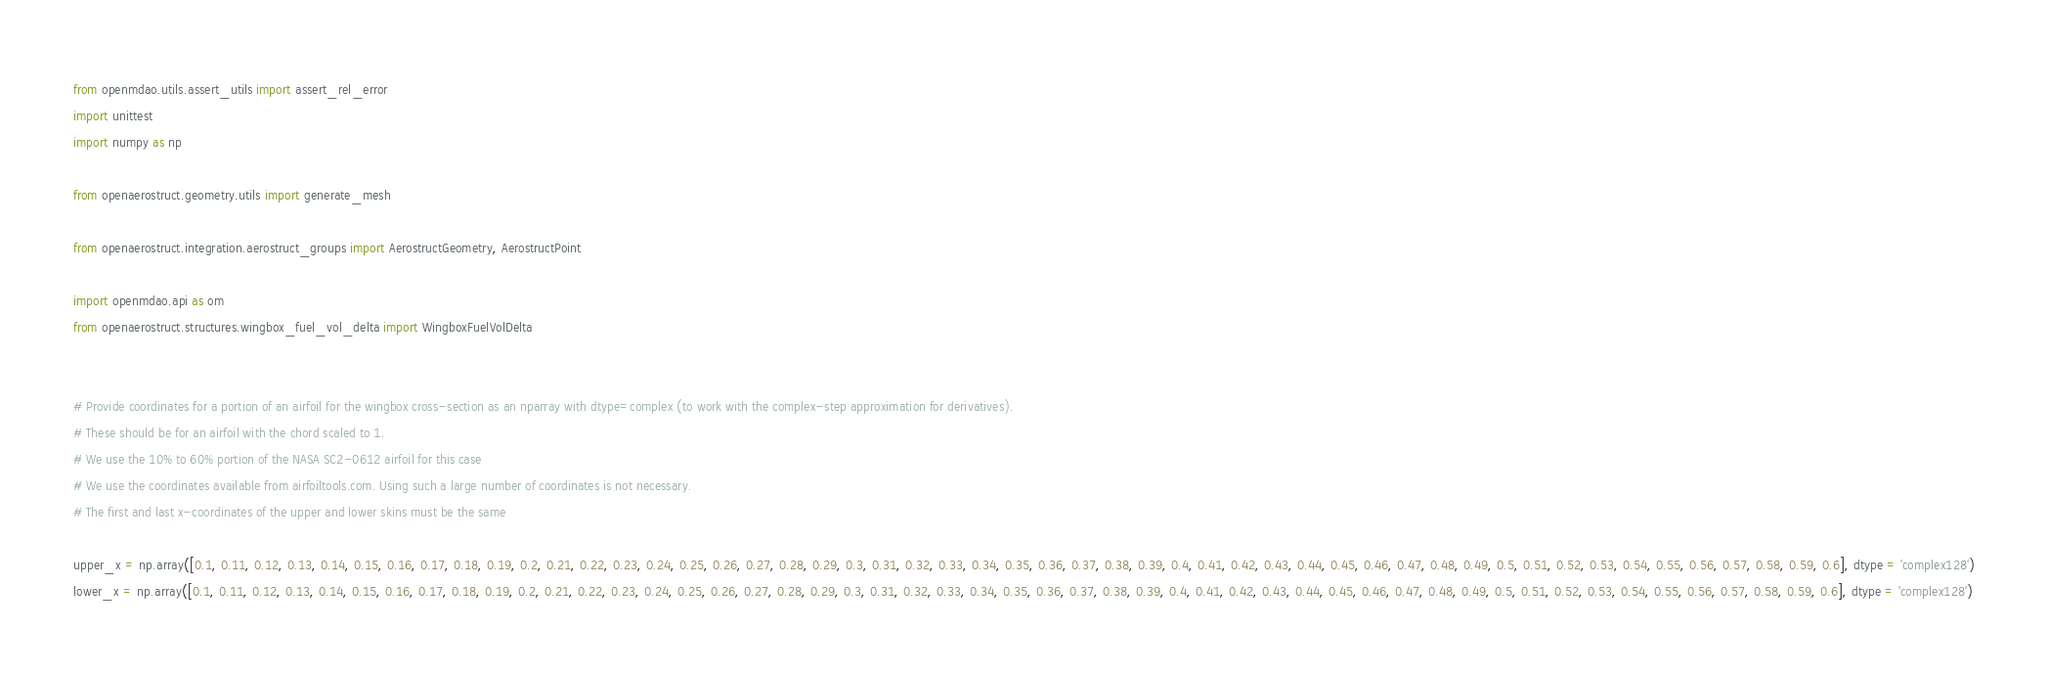Convert code to text. <code><loc_0><loc_0><loc_500><loc_500><_Python_>from openmdao.utils.assert_utils import assert_rel_error
import unittest
import numpy as np

from openaerostruct.geometry.utils import generate_mesh

from openaerostruct.integration.aerostruct_groups import AerostructGeometry, AerostructPoint

import openmdao.api as om
from openaerostruct.structures.wingbox_fuel_vol_delta import WingboxFuelVolDelta


# Provide coordinates for a portion of an airfoil for the wingbox cross-section as an nparray with dtype=complex (to work with the complex-step approximation for derivatives).
# These should be for an airfoil with the chord scaled to 1.
# We use the 10% to 60% portion of the NASA SC2-0612 airfoil for this case
# We use the coordinates available from airfoiltools.com. Using such a large number of coordinates is not necessary.
# The first and last x-coordinates of the upper and lower skins must be the same

upper_x = np.array([0.1, 0.11, 0.12, 0.13, 0.14, 0.15, 0.16, 0.17, 0.18, 0.19, 0.2, 0.21, 0.22, 0.23, 0.24, 0.25, 0.26, 0.27, 0.28, 0.29, 0.3, 0.31, 0.32, 0.33, 0.34, 0.35, 0.36, 0.37, 0.38, 0.39, 0.4, 0.41, 0.42, 0.43, 0.44, 0.45, 0.46, 0.47, 0.48, 0.49, 0.5, 0.51, 0.52, 0.53, 0.54, 0.55, 0.56, 0.57, 0.58, 0.59, 0.6], dtype = 'complex128')
lower_x = np.array([0.1, 0.11, 0.12, 0.13, 0.14, 0.15, 0.16, 0.17, 0.18, 0.19, 0.2, 0.21, 0.22, 0.23, 0.24, 0.25, 0.26, 0.27, 0.28, 0.29, 0.3, 0.31, 0.32, 0.33, 0.34, 0.35, 0.36, 0.37, 0.38, 0.39, 0.4, 0.41, 0.42, 0.43, 0.44, 0.45, 0.46, 0.47, 0.48, 0.49, 0.5, 0.51, 0.52, 0.53, 0.54, 0.55, 0.56, 0.57, 0.58, 0.59, 0.6], dtype = 'complex128')</code> 